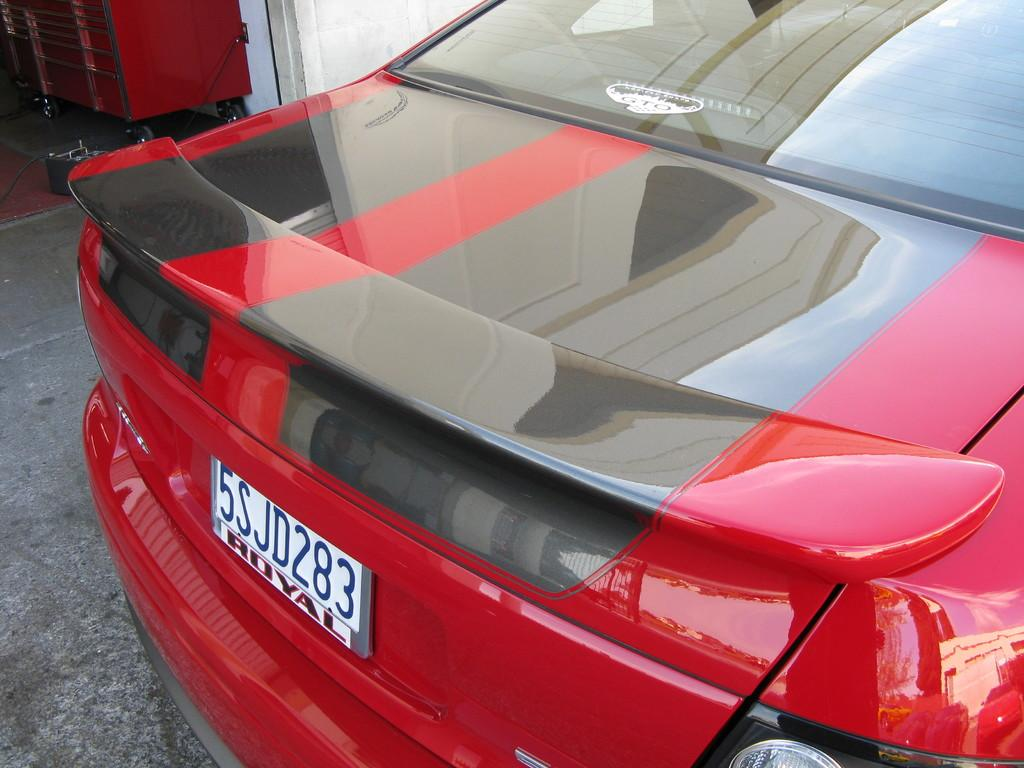What type of vehicle is in the image? There is a red car in the image. What can be seen on the car? The car has a number plate. What is at the bottom of the image? There is a road at the bottom of the image. What is located in the top part of the image? There is a box with wheels, a wall, an unspecified object, and a wire in the top part of the image. What brand of toothpaste is advertised on the wall in the image? There is no toothpaste or advertisement present in the image. How is the religion represented in the image? There is no indication of religion in the image. 